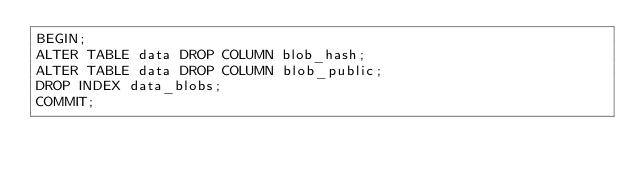Convert code to text. <code><loc_0><loc_0><loc_500><loc_500><_SQL_>BEGIN;
ALTER TABLE data DROP COLUMN blob_hash;
ALTER TABLE data DROP COLUMN blob_public;
DROP INDEX data_blobs;
COMMIT;
</code> 